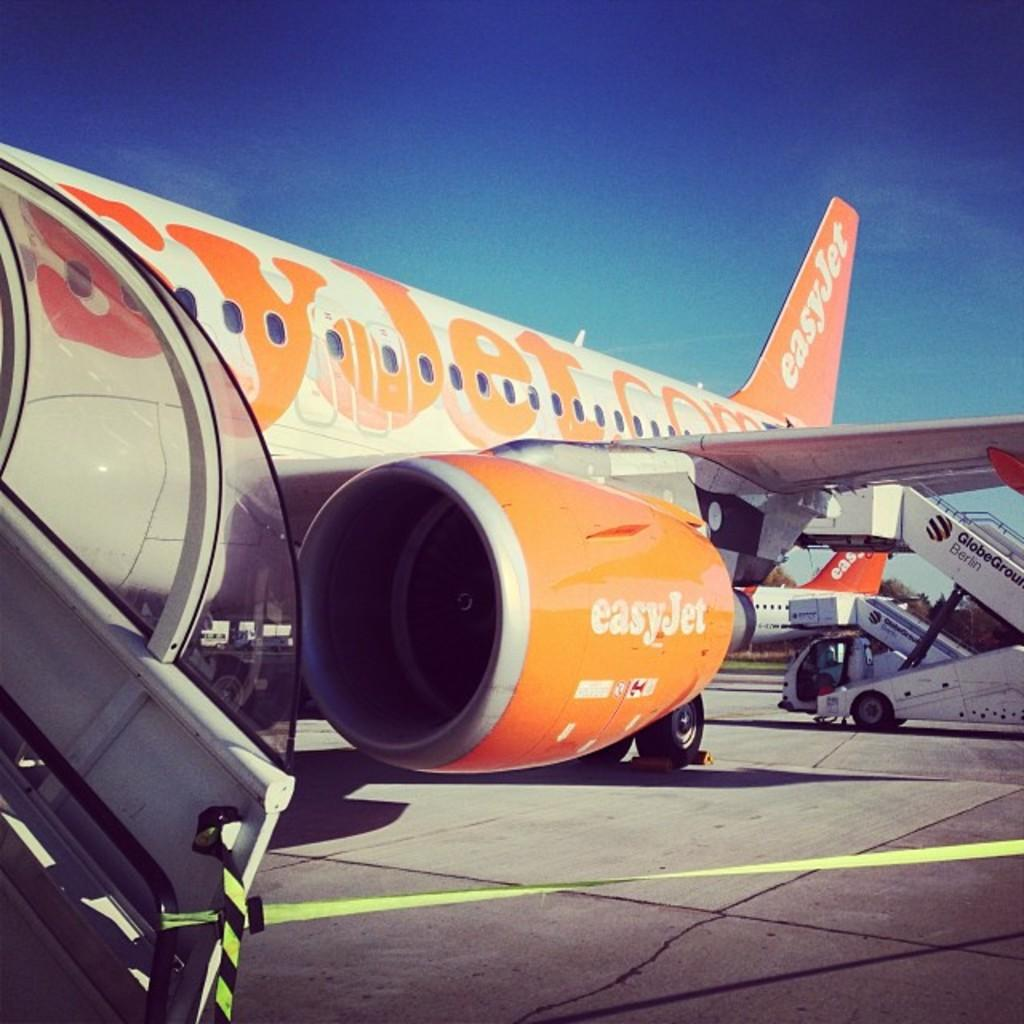<image>
Summarize the visual content of the image. At a Berlin airport, a movable staircase is driven up to an EasyJet plane. 